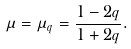Convert formula to latex. <formula><loc_0><loc_0><loc_500><loc_500>\mu = \mu _ { q } = \frac { 1 - 2 q } { 1 + 2 q } .</formula> 